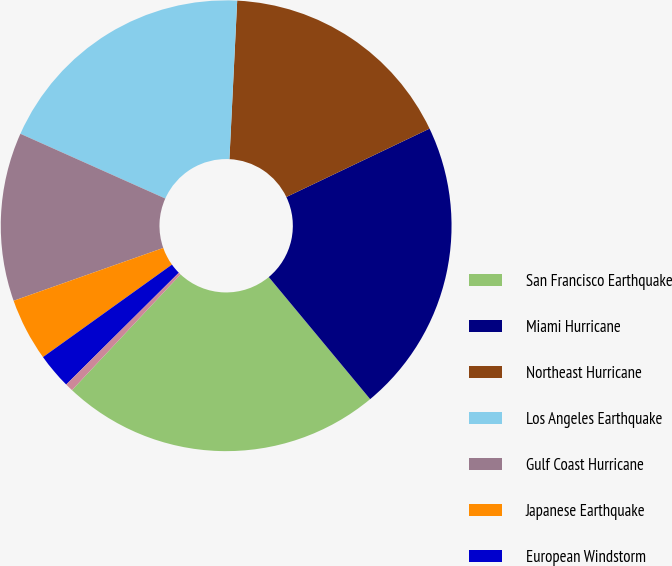Convert chart to OTSL. <chart><loc_0><loc_0><loc_500><loc_500><pie_chart><fcel>San Francisco Earthquake<fcel>Miami Hurricane<fcel>Northeast Hurricane<fcel>Los Angeles Earthquake<fcel>Gulf Coast Hurricane<fcel>Japanese Earthquake<fcel>European Windstorm<fcel>Japanese Typhoon<nl><fcel>23.02%<fcel>21.06%<fcel>17.13%<fcel>19.09%<fcel>12.09%<fcel>4.5%<fcel>2.54%<fcel>0.57%<nl></chart> 